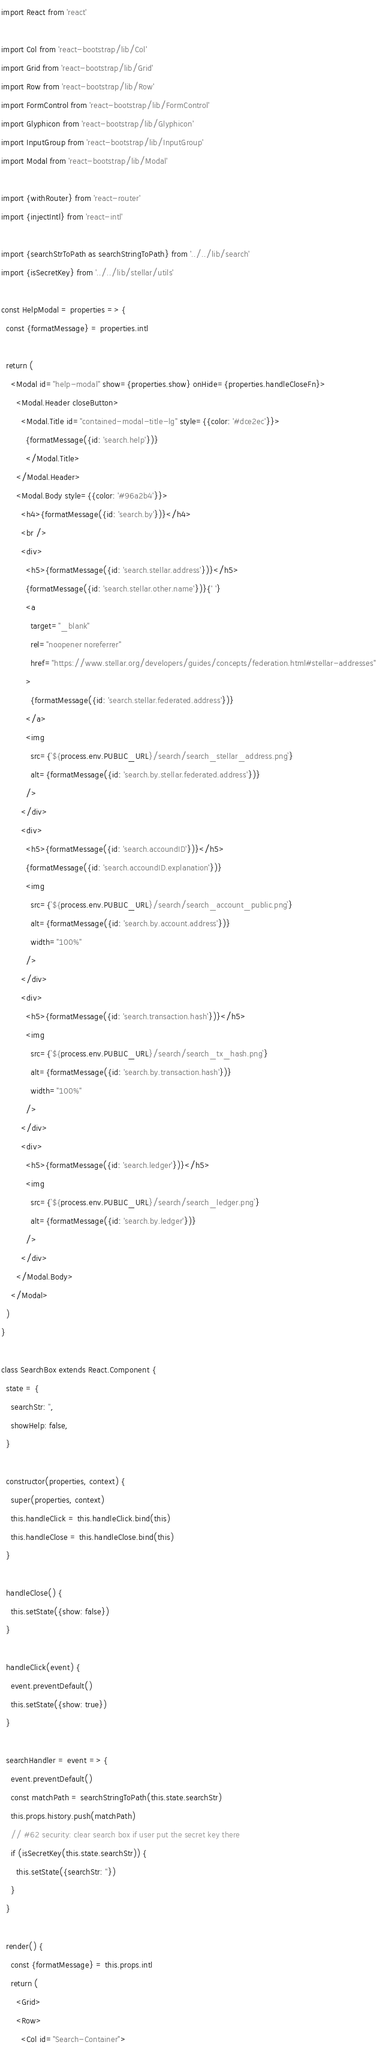<code> <loc_0><loc_0><loc_500><loc_500><_JavaScript_>import React from 'react'

import Col from 'react-bootstrap/lib/Col'
import Grid from 'react-bootstrap/lib/Grid'
import Row from 'react-bootstrap/lib/Row'
import FormControl from 'react-bootstrap/lib/FormControl'
import Glyphicon from 'react-bootstrap/lib/Glyphicon'
import InputGroup from 'react-bootstrap/lib/InputGroup'
import Modal from 'react-bootstrap/lib/Modal'

import {withRouter} from 'react-router'
import {injectIntl} from 'react-intl'

import {searchStrToPath as searchStringToPath} from '../../lib/search'
import {isSecretKey} from '../../lib/stellar/utils'

const HelpModal = properties => {
  const {formatMessage} = properties.intl

  return (
    <Modal id="help-modal" show={properties.show} onHide={properties.handleCloseFn}>
      <Modal.Header closeButton>
        <Modal.Title id="contained-modal-title-lg" style={{color: '#dce2ec'}}>
          {formatMessage({id: 'search.help'})}
          </Modal.Title>
      </Modal.Header>
      <Modal.Body style={{color: '#96a2b4'}}>
        <h4>{formatMessage({id: 'search.by'})}</h4>
        <br />
        <div>
          <h5>{formatMessage({id: 'search.stellar.address'})}</h5>
          {formatMessage({id: 'search.stellar.other.name'})}{' '}
          <a
            target="_blank"
            rel="noopener noreferrer"
            href="https://www.stellar.org/developers/guides/concepts/federation.html#stellar-addresses"
          >
            {formatMessage({id: 'search.stellar.federated.address'})}
          </a>
          <img
            src={`${process.env.PUBLIC_URL}/search/search_stellar_address.png`}
            alt={formatMessage({id: 'search.by.stellar.federated.address'})}
          />
        </div>
        <div>
          <h5>{formatMessage({id: 'search.accoundID'})}</h5>
          {formatMessage({id: 'search.accoundID.explanation'})}
          <img
            src={`${process.env.PUBLIC_URL}/search/search_account_public.png`}
            alt={formatMessage({id: 'search.by.account.address'})}
            width="100%"
          />
        </div>
        <div>
          <h5>{formatMessage({id: 'search.transaction.hash'})}</h5>
          <img
            src={`${process.env.PUBLIC_URL}/search/search_tx_hash.png`}
            alt={formatMessage({id: 'search.by.transaction.hash'})}
            width="100%"
          />
        </div>
        <div>
          <h5>{formatMessage({id: 'search.ledger'})}</h5>
          <img
            src={`${process.env.PUBLIC_URL}/search/search_ledger.png`}
            alt={formatMessage({id: 'search.by.ledger'})}
          />
        </div>
      </Modal.Body>
    </Modal>
  )
}

class SearchBox extends React.Component {
  state = {
    searchStr: '',
    showHelp: false,
  }

  constructor(properties, context) {
    super(properties, context)
    this.handleClick = this.handleClick.bind(this)
    this.handleClose = this.handleClose.bind(this)
  }

  handleClose() {
    this.setState({show: false})
  }

  handleClick(event) {
    event.preventDefault()
    this.setState({show: true})
  }

  searchHandler = event => {
    event.preventDefault()
    const matchPath = searchStringToPath(this.state.searchStr)
    this.props.history.push(matchPath)
    // #62 security: clear search box if user put the secret key there
    if (isSecretKey(this.state.searchStr)) {
      this.setState({searchStr: ''})
    }
  }

  render() {
    const {formatMessage} = this.props.intl
    return (
      <Grid>
      <Row>
        <Col id="Search-Container"></code> 